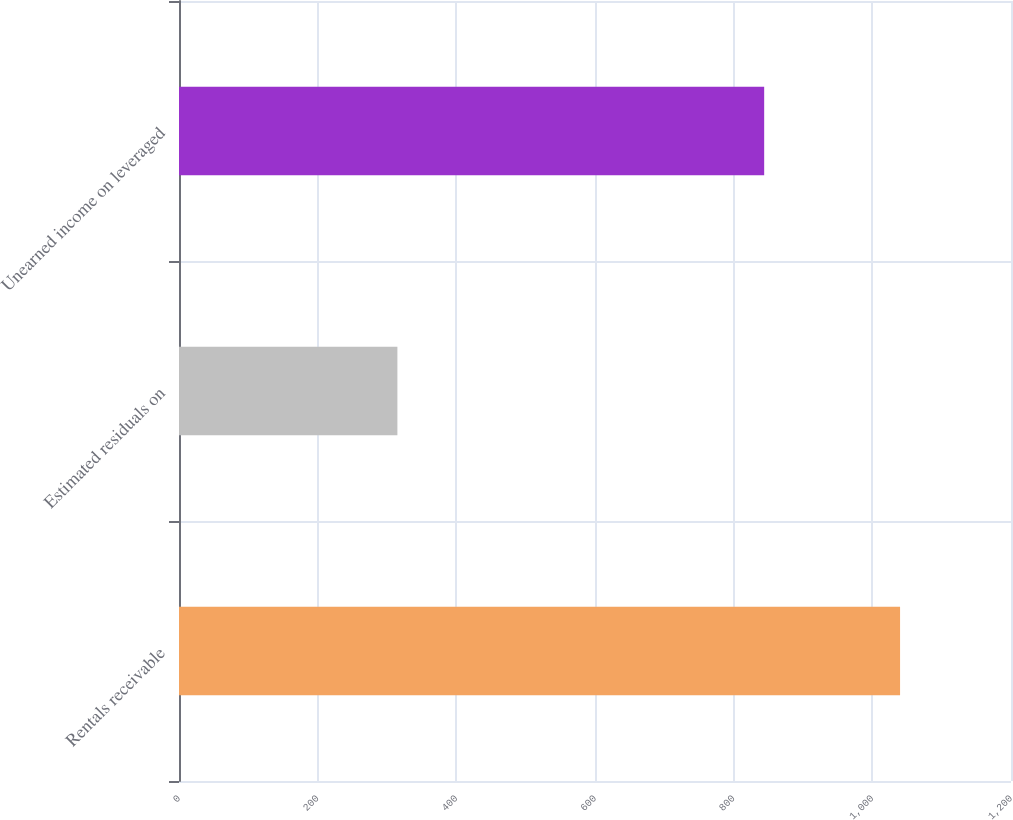Convert chart to OTSL. <chart><loc_0><loc_0><loc_500><loc_500><bar_chart><fcel>Rentals receivable<fcel>Estimated residuals on<fcel>Unearned income on leveraged<nl><fcel>1040<fcel>315<fcel>844<nl></chart> 